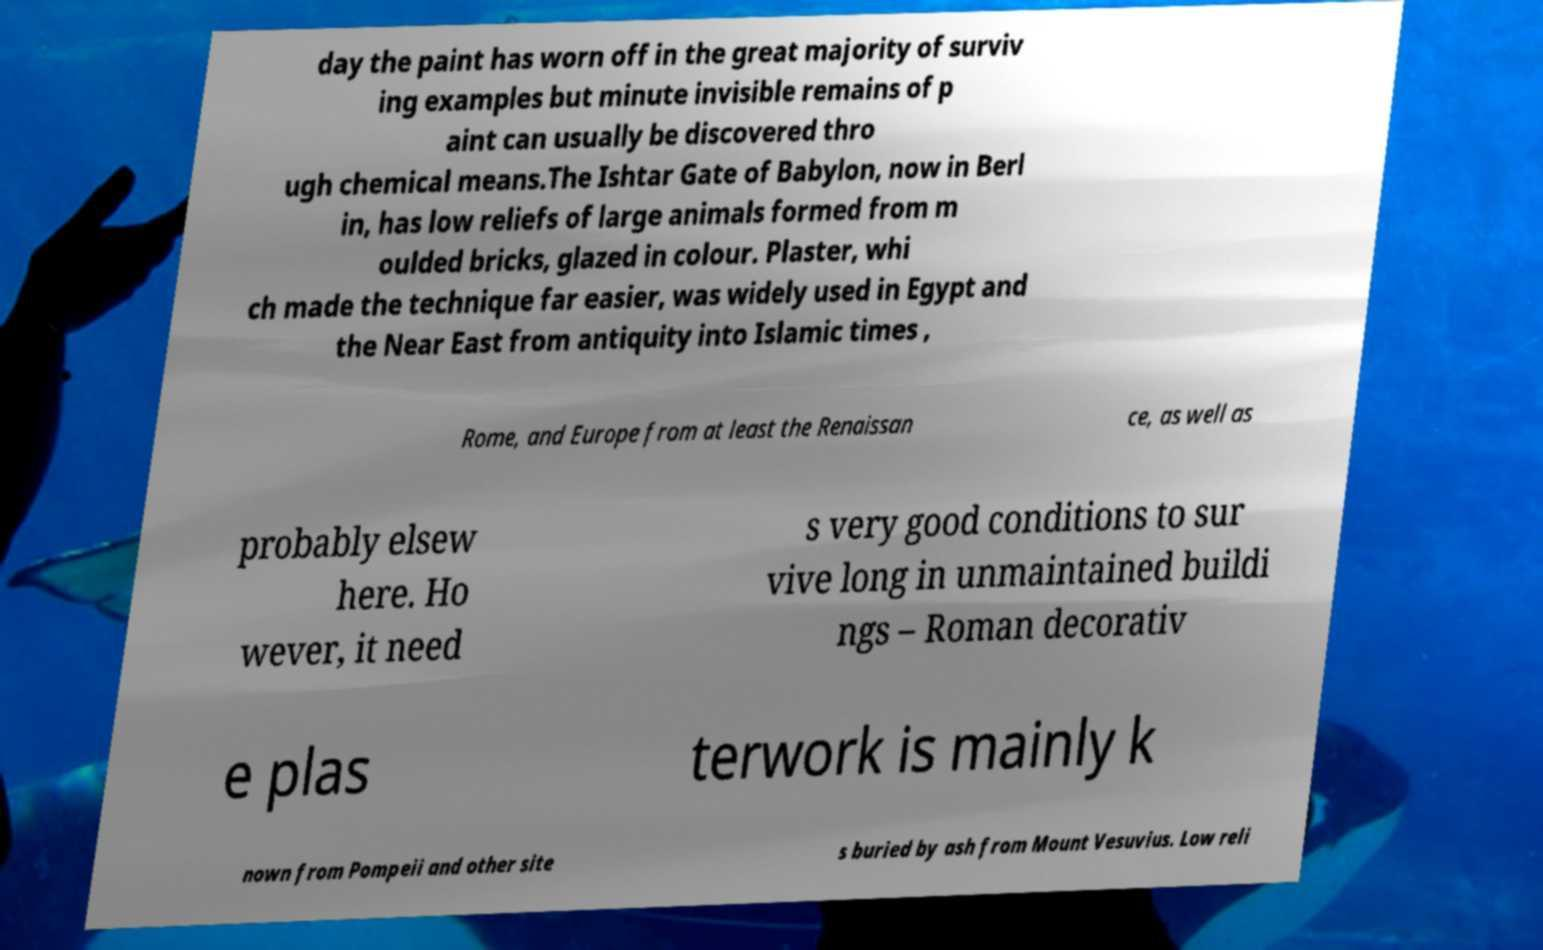What messages or text are displayed in this image? I need them in a readable, typed format. day the paint has worn off in the great majority of surviv ing examples but minute invisible remains of p aint can usually be discovered thro ugh chemical means.The Ishtar Gate of Babylon, now in Berl in, has low reliefs of large animals formed from m oulded bricks, glazed in colour. Plaster, whi ch made the technique far easier, was widely used in Egypt and the Near East from antiquity into Islamic times , Rome, and Europe from at least the Renaissan ce, as well as probably elsew here. Ho wever, it need s very good conditions to sur vive long in unmaintained buildi ngs – Roman decorativ e plas terwork is mainly k nown from Pompeii and other site s buried by ash from Mount Vesuvius. Low reli 